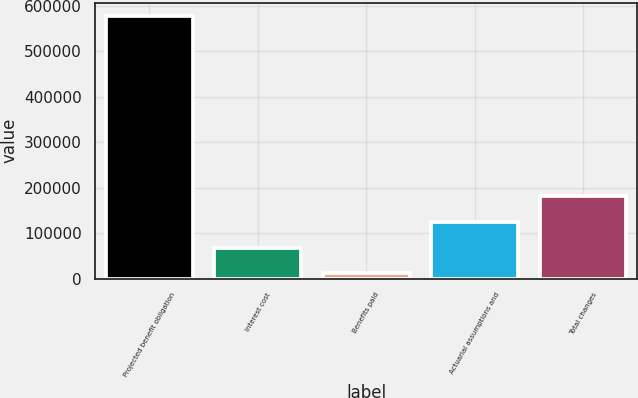Convert chart to OTSL. <chart><loc_0><loc_0><loc_500><loc_500><bar_chart><fcel>Projected benefit obligation<fcel>Interest cost<fcel>Benefits paid<fcel>Actuarial assumptions and<fcel>Total changes<nl><fcel>577770<fcel>68007.3<fcel>11367<fcel>124648<fcel>181288<nl></chart> 